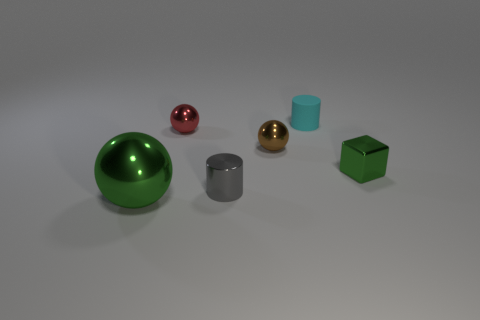Add 2 green rubber cubes. How many objects exist? 8 Subtract all blocks. How many objects are left? 5 Subtract all purple shiny cubes. Subtract all tiny gray shiny cylinders. How many objects are left? 5 Add 6 small blocks. How many small blocks are left? 7 Add 5 small matte cylinders. How many small matte cylinders exist? 6 Subtract 0 red cubes. How many objects are left? 6 